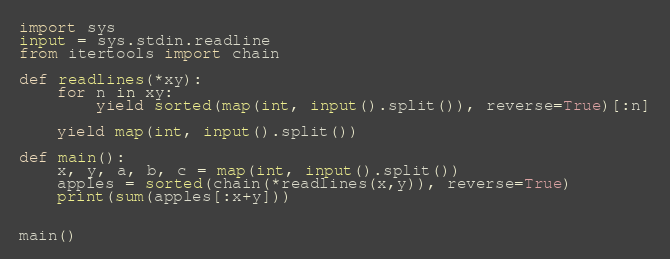Convert code to text. <code><loc_0><loc_0><loc_500><loc_500><_Python_>import sys
input = sys.stdin.readline
from itertools import chain

def readlines(*xy):
    for n in xy:
        yield sorted(map(int, input().split()), reverse=True)[:n]
    
    yield map(int, input().split())

def main():
    x, y, a, b, c = map(int, input().split())
    apples = sorted(chain(*readlines(x,y)), reverse=True)
    print(sum(apples[:x+y]))


main()


</code> 